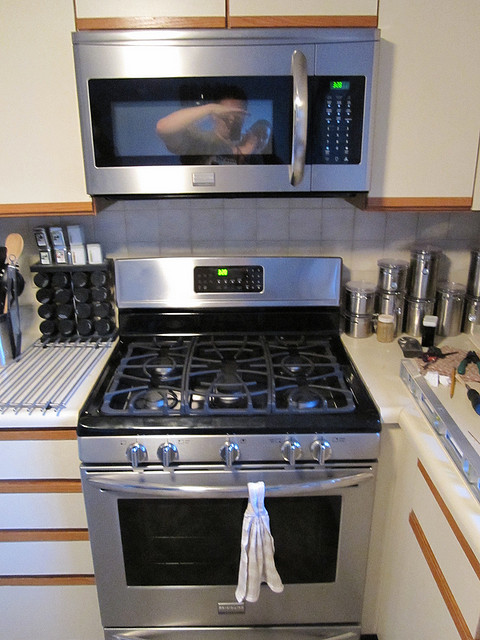How many people are reflected in the microwave window? 1 